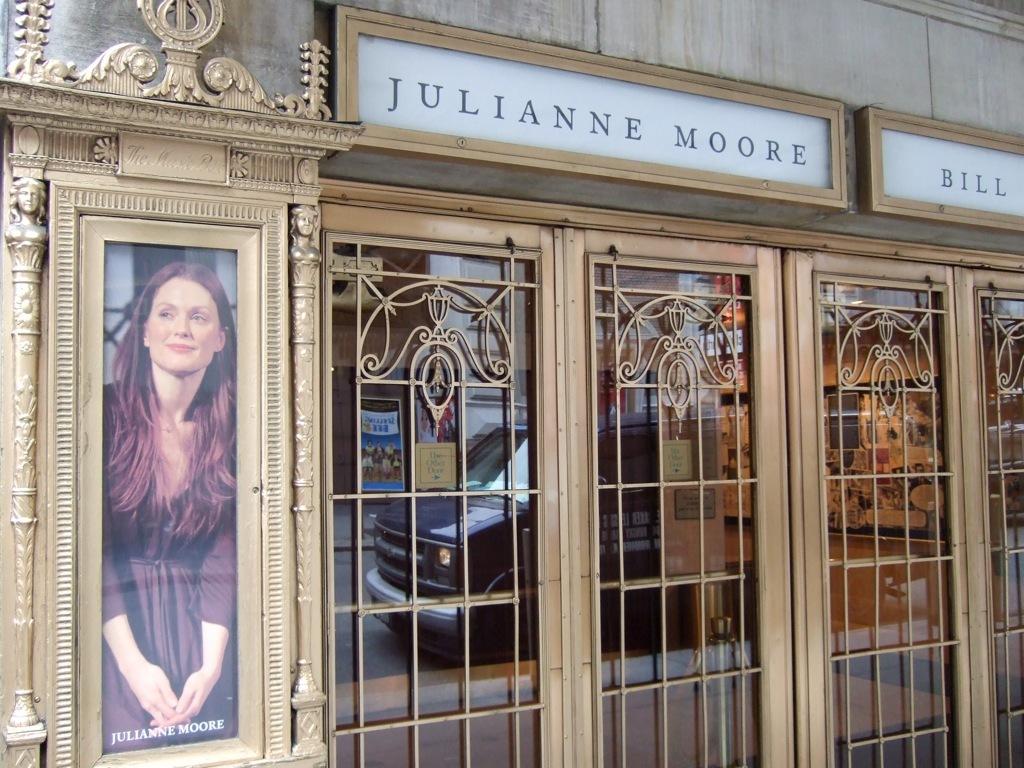What actress is shown here?
Make the answer very short. Julianne moore. What male name can you see on the very top right?
Provide a succinct answer. Bill. 